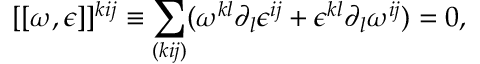Convert formula to latex. <formula><loc_0><loc_0><loc_500><loc_500>[ [ \omega , \epsilon ] ] ^ { k i j } \equiv \sum _ { ( k i j ) } ( \omega ^ { k l } \partial _ { l } \epsilon ^ { i j } + \epsilon ^ { k l } \partial _ { l } \omega ^ { i j } ) = 0 ,</formula> 